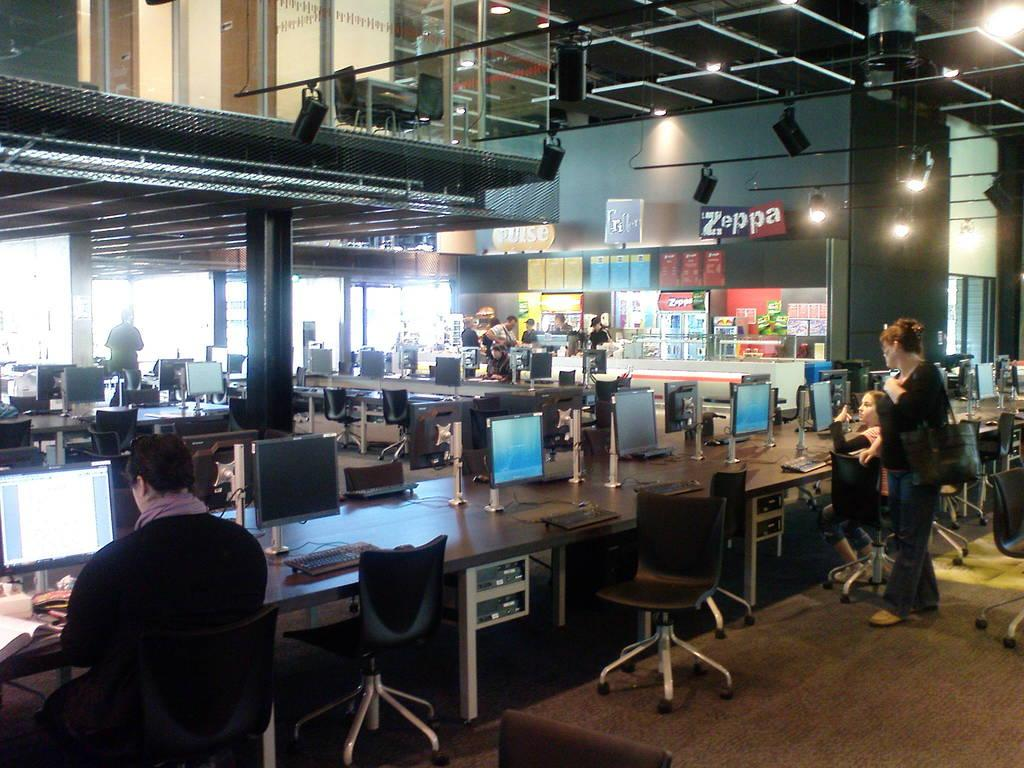What type of furniture is present in the image? There are chairs and tables in the image. What objects are on top of the tables? There are laptops on the tables. Are there any people in the image? Yes, there are people standing in the image. What type of garden can be seen in the image? There is no garden present in the image. Can you tell me how many beginner-level cat toys are on the tables? There are no cat toys or any reference to a cat in the image. 